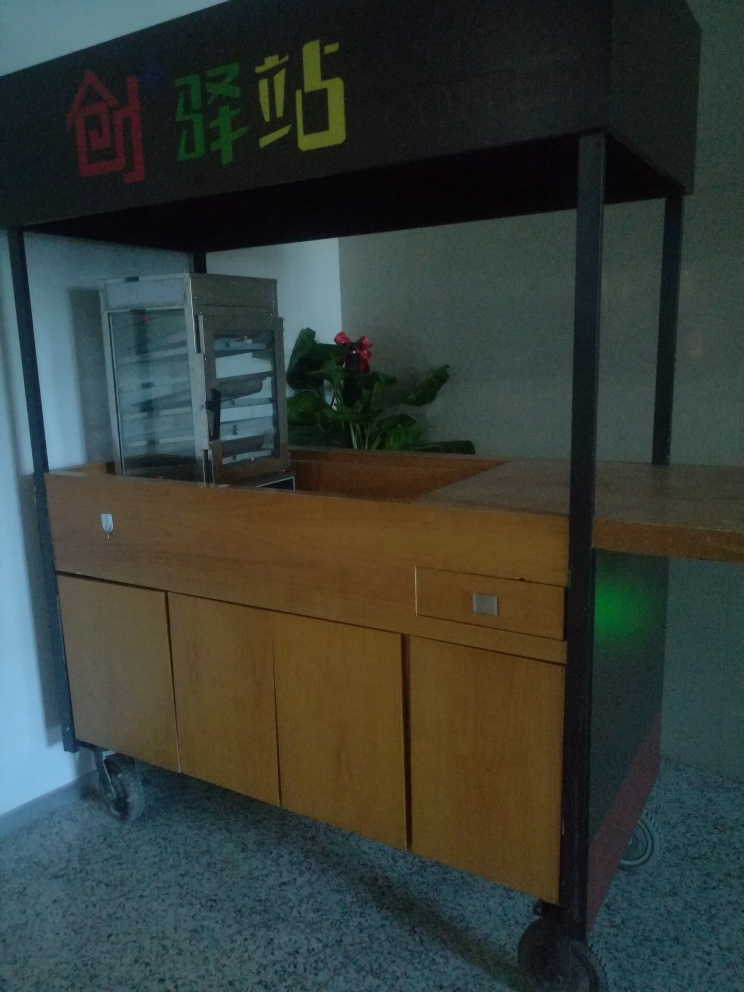Are there any quality issues with this image? Yes, there are several quality issues with this image. Firstly, it appears to be taken in low lighting conditions, resulting in a lack of clarity and visible noise. Secondly, the image is not well-composed, with a large portion of the frame taken up by empty space, which does not contribute to the focus of the image. Lastly, the angle and perspective could be improved for better presentation of the subject. 